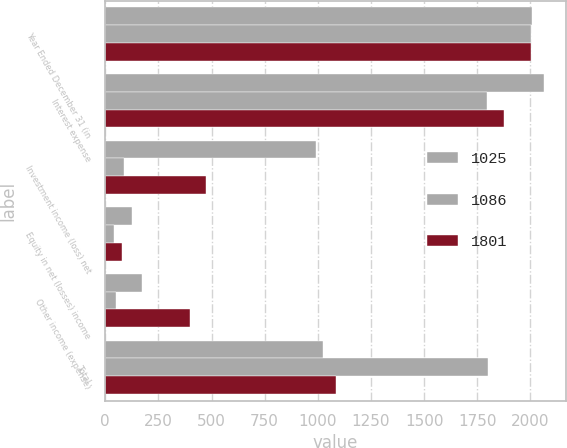Convert chart to OTSL. <chart><loc_0><loc_0><loc_500><loc_500><stacked_bar_chart><ecel><fcel>Year Ended December 31 (in<fcel>Interest expense<fcel>Investment income (loss) net<fcel>Equity in net (losses) income<fcel>Other income (expense)<fcel>Total<nl><fcel>1025<fcel>2006<fcel>2064<fcel>990<fcel>124<fcel>173<fcel>1025<nl><fcel>1086<fcel>2005<fcel>1795<fcel>89<fcel>42<fcel>53<fcel>1801<nl><fcel>1801<fcel>2004<fcel>1874<fcel>472<fcel>81<fcel>397<fcel>1086<nl></chart> 